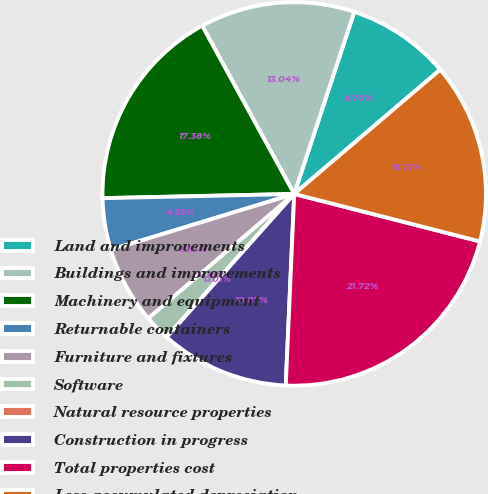<chart> <loc_0><loc_0><loc_500><loc_500><pie_chart><fcel>Land and improvements<fcel>Buildings and improvements<fcel>Machinery and equipment<fcel>Returnable containers<fcel>Furniture and fixtures<fcel>Software<fcel>Natural resource properties<fcel>Construction in progress<fcel>Total properties cost<fcel>Less accumulated depreciation<nl><fcel>8.7%<fcel>13.04%<fcel>17.38%<fcel>4.35%<fcel>6.53%<fcel>2.18%<fcel>0.01%<fcel>10.87%<fcel>21.72%<fcel>15.21%<nl></chart> 